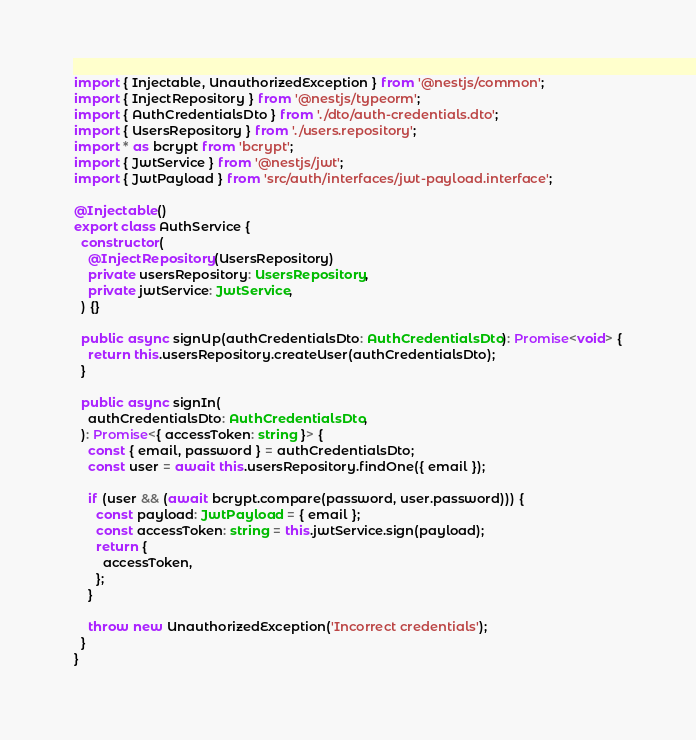<code> <loc_0><loc_0><loc_500><loc_500><_TypeScript_>import { Injectable, UnauthorizedException } from '@nestjs/common';
import { InjectRepository } from '@nestjs/typeorm';
import { AuthCredentialsDto } from './dto/auth-credentials.dto';
import { UsersRepository } from './users.repository';
import * as bcrypt from 'bcrypt';
import { JwtService } from '@nestjs/jwt';
import { JwtPayload } from 'src/auth/interfaces/jwt-payload.interface';

@Injectable()
export class AuthService {
  constructor(
    @InjectRepository(UsersRepository)
    private usersRepository: UsersRepository,
    private jwtService: JwtService,
  ) {}

  public async signUp(authCredentialsDto: AuthCredentialsDto): Promise<void> {
    return this.usersRepository.createUser(authCredentialsDto);
  }

  public async signIn(
    authCredentialsDto: AuthCredentialsDto,
  ): Promise<{ accessToken: string }> {
    const { email, password } = authCredentialsDto;
    const user = await this.usersRepository.findOne({ email });

    if (user && (await bcrypt.compare(password, user.password))) {
      const payload: JwtPayload = { email };
      const accessToken: string = this.jwtService.sign(payload);
      return {
        accessToken,
      };
    }

    throw new UnauthorizedException('Incorrect credentials');
  }
}
</code> 